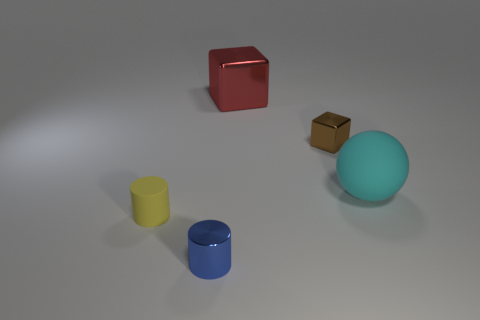Add 4 small blocks. How many objects exist? 9 Subtract all blocks. How many objects are left? 3 Subtract all large red objects. Subtract all small blue objects. How many objects are left? 3 Add 5 cubes. How many cubes are left? 7 Add 3 tiny yellow matte cylinders. How many tiny yellow matte cylinders exist? 4 Subtract 0 gray cubes. How many objects are left? 5 